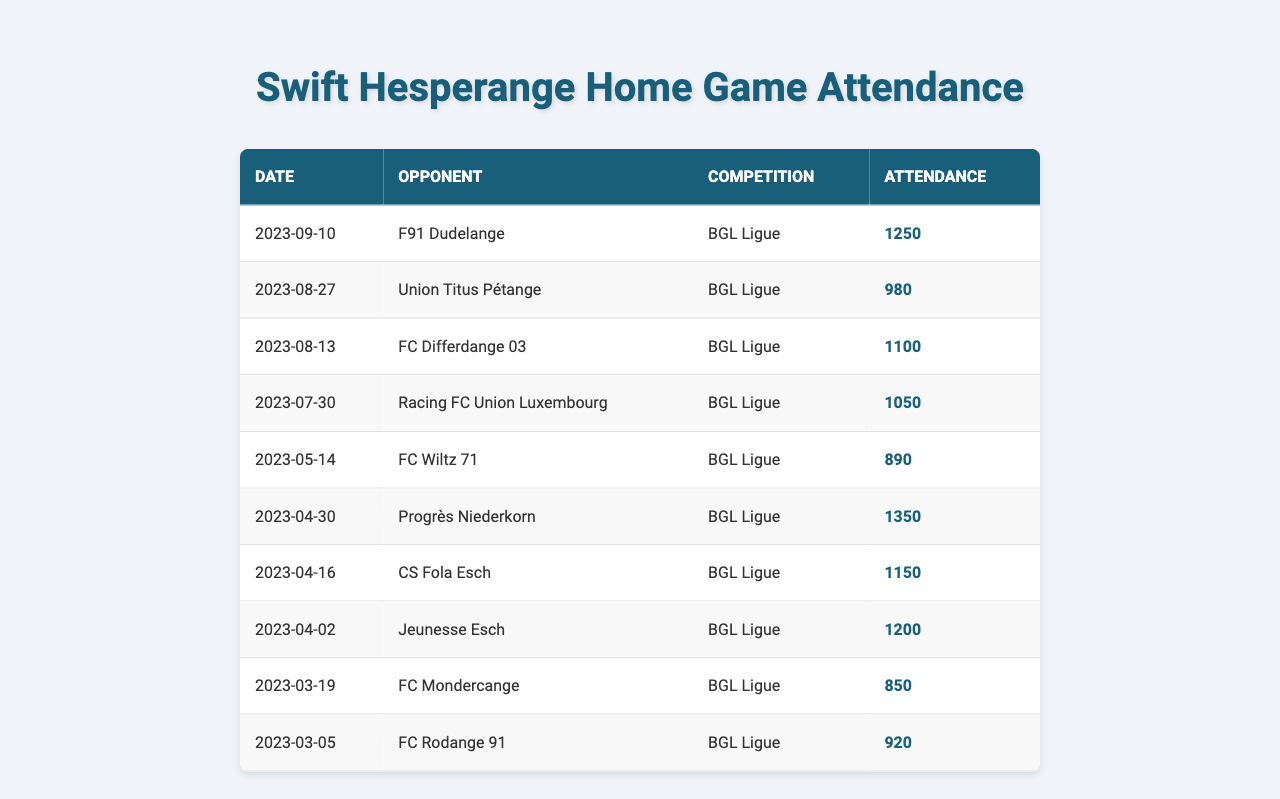What was the attendance for the match against F91 Dudelange? The attendance figure for the match on September 10, 2023, against F91 Dudelange is listed in the table as 1250.
Answer: 1250 What is the total attendance for all matches listed in the table? To find the total attendance, sum all individual attendance figures: 1250 + 980 + 1100 + 1050 + 890 + 1350 + 1150 + 1200 + 850 + 920 = 10,320.
Answer: 10320 Which match had the highest attendance? The highest attendance figure is 1350, which occurred during the match against Progrès Niederkorn on April 30, 2023.
Answer: Progrès Niederkorn Did Swift Hesperange ever have an attendance below 900? Yes, the match against FC Wiltz 71 on May 14, 2023, had an attendance of 890, which is below 900.
Answer: Yes What is the average attendance across all listed matches? The total attendance is 10,320, and there are 10 matches. Therefore, the average attendance is 10,320 divided by 10, which equals 1032.
Answer: 1032 How many matches had an attendance greater than 1000? Counting the entries, six matches had an attendance greater than 1000 (1250, 1100, 1050, 1350, 1150, and 1200).
Answer: 6 What is the difference in attendance between the highest and lowest match? The highest attendance is 1350 (Progrès Niederkorn) and the lowest is 850 (FC Mondercange). The difference is 1350 - 850 = 500.
Answer: 500 Which opponent had the lowest attendance? The opponent with the lowest attendance is FC Mondercange, with an attendance of 850.
Answer: FC Mondercange How many matches were played in August? There are three matches in August: FC Differdange 03, Union Titus Pétange, and one more match on July 30 which is not in August, resulting in 2 games.
Answer: 2 Was there an increase in attendance from the match against FC Differdange 03 to the match against Progrès Niederkorn? The attendance for FC Differdange 03 was 1100 and for Progrès Niederkorn it was 1350. Since 1350 is greater than 1100, there was an increase.
Answer: Yes 